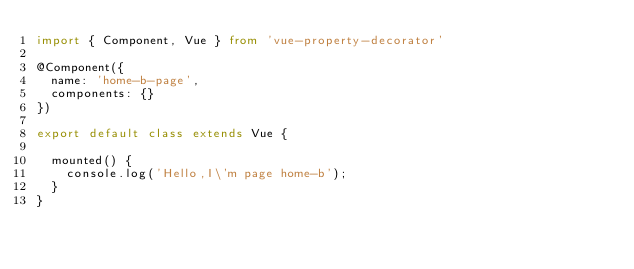Convert code to text. <code><loc_0><loc_0><loc_500><loc_500><_TypeScript_>import { Component, Vue } from 'vue-property-decorator'

@Component({
  name: 'home-b-page',
  components: {}
})

export default class extends Vue {

  mounted() {
    console.log('Hello,I\'m page home-b');
  }
}</code> 